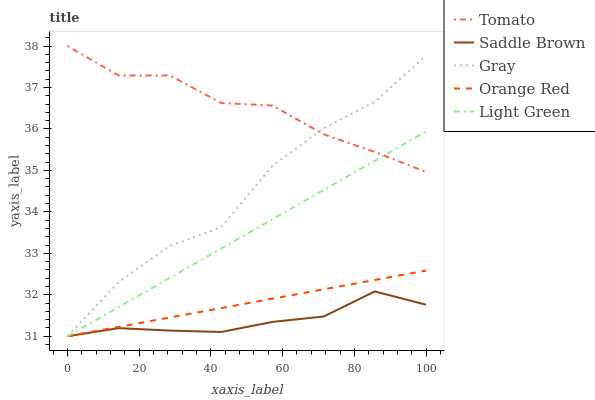Does Saddle Brown have the minimum area under the curve?
Answer yes or no. Yes. Does Tomato have the maximum area under the curve?
Answer yes or no. Yes. Does Gray have the minimum area under the curve?
Answer yes or no. No. Does Gray have the maximum area under the curve?
Answer yes or no. No. Is Light Green the smoothest?
Answer yes or no. Yes. Is Gray the roughest?
Answer yes or no. Yes. Is Saddle Brown the smoothest?
Answer yes or no. No. Is Saddle Brown the roughest?
Answer yes or no. No. Does Gray have the lowest value?
Answer yes or no. Yes. Does Tomato have the highest value?
Answer yes or no. Yes. Does Gray have the highest value?
Answer yes or no. No. Is Orange Red less than Tomato?
Answer yes or no. Yes. Is Tomato greater than Saddle Brown?
Answer yes or no. Yes. Does Gray intersect Saddle Brown?
Answer yes or no. Yes. Is Gray less than Saddle Brown?
Answer yes or no. No. Is Gray greater than Saddle Brown?
Answer yes or no. No. Does Orange Red intersect Tomato?
Answer yes or no. No. 